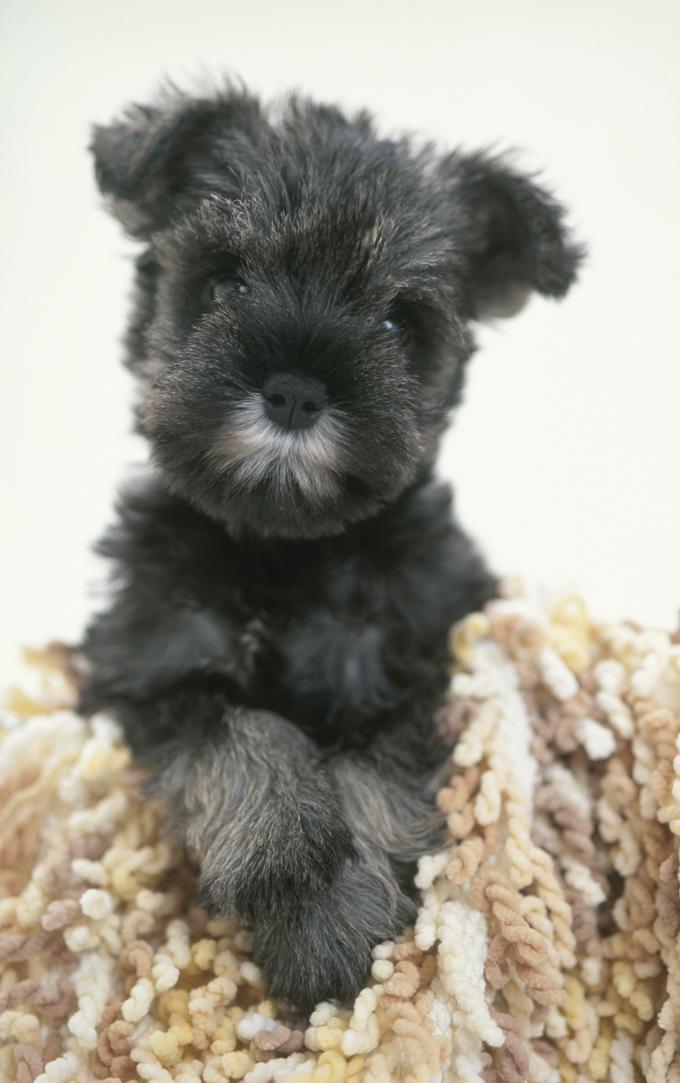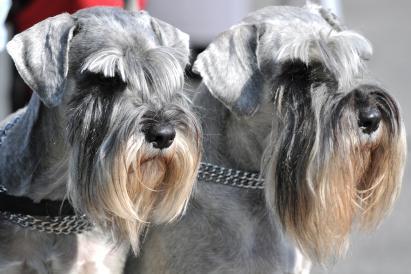The first image is the image on the left, the second image is the image on the right. Assess this claim about the two images: "In one image there is a dog outside with some grass in the image.". Correct or not? Answer yes or no. No. The first image is the image on the left, the second image is the image on the right. Evaluate the accuracy of this statement regarding the images: "There is one image of a mostly black dog and one of at least one gray dog.". Is it true? Answer yes or no. Yes. 